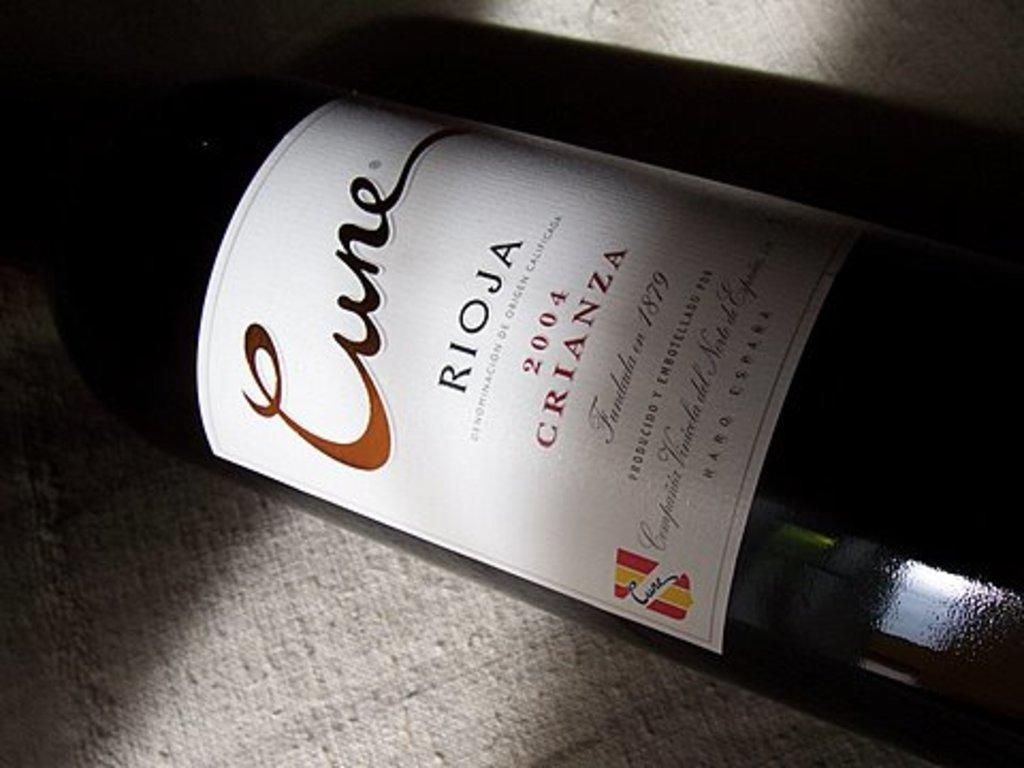<image>
Describe the image concisely. A 2004 bottle of Crianza, founded in 1879. 